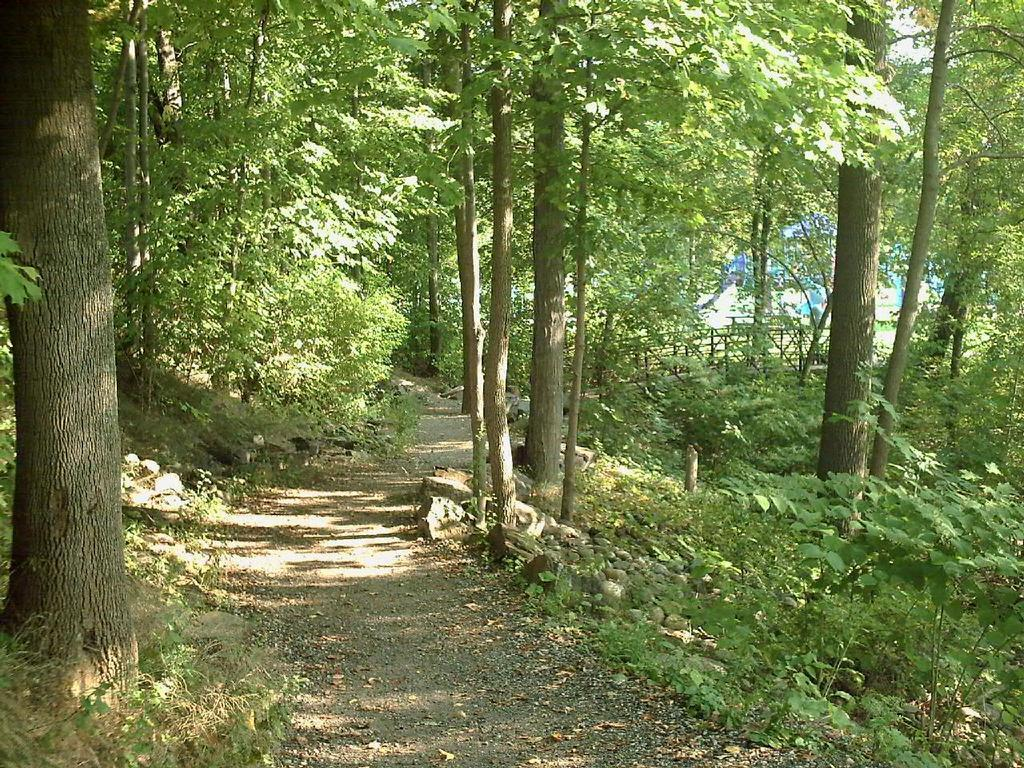What type of vegetation can be seen in the image? There are trees and plants in the image. What type of ground surface is visible in the image? There are stones and a road in the image. What structures can be seen in the image? There is fencing and a wall in the image. Can you describe the duck's surprise at the unique design of the wall in the image? There is no duck present in the image, and therefore no such surprise or design can be observed. 